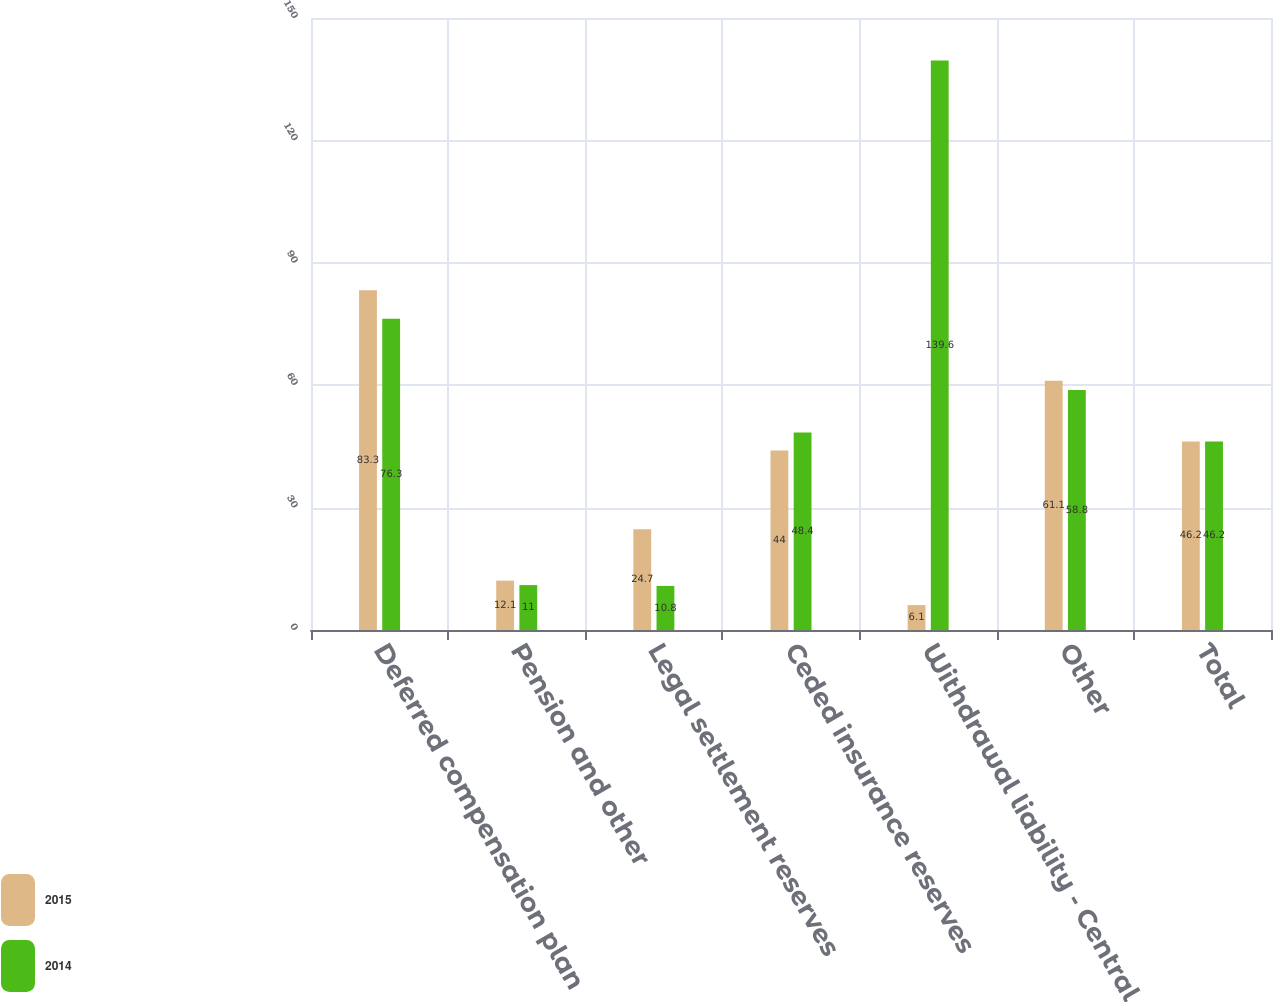Convert chart. <chart><loc_0><loc_0><loc_500><loc_500><stacked_bar_chart><ecel><fcel>Deferred compensation plan<fcel>Pension and other<fcel>Legal settlement reserves<fcel>Ceded insurance reserves<fcel>Withdrawal liability - Central<fcel>Other<fcel>Total<nl><fcel>2015<fcel>83.3<fcel>12.1<fcel>24.7<fcel>44<fcel>6.1<fcel>61.1<fcel>46.2<nl><fcel>2014<fcel>76.3<fcel>11<fcel>10.8<fcel>48.4<fcel>139.6<fcel>58.8<fcel>46.2<nl></chart> 